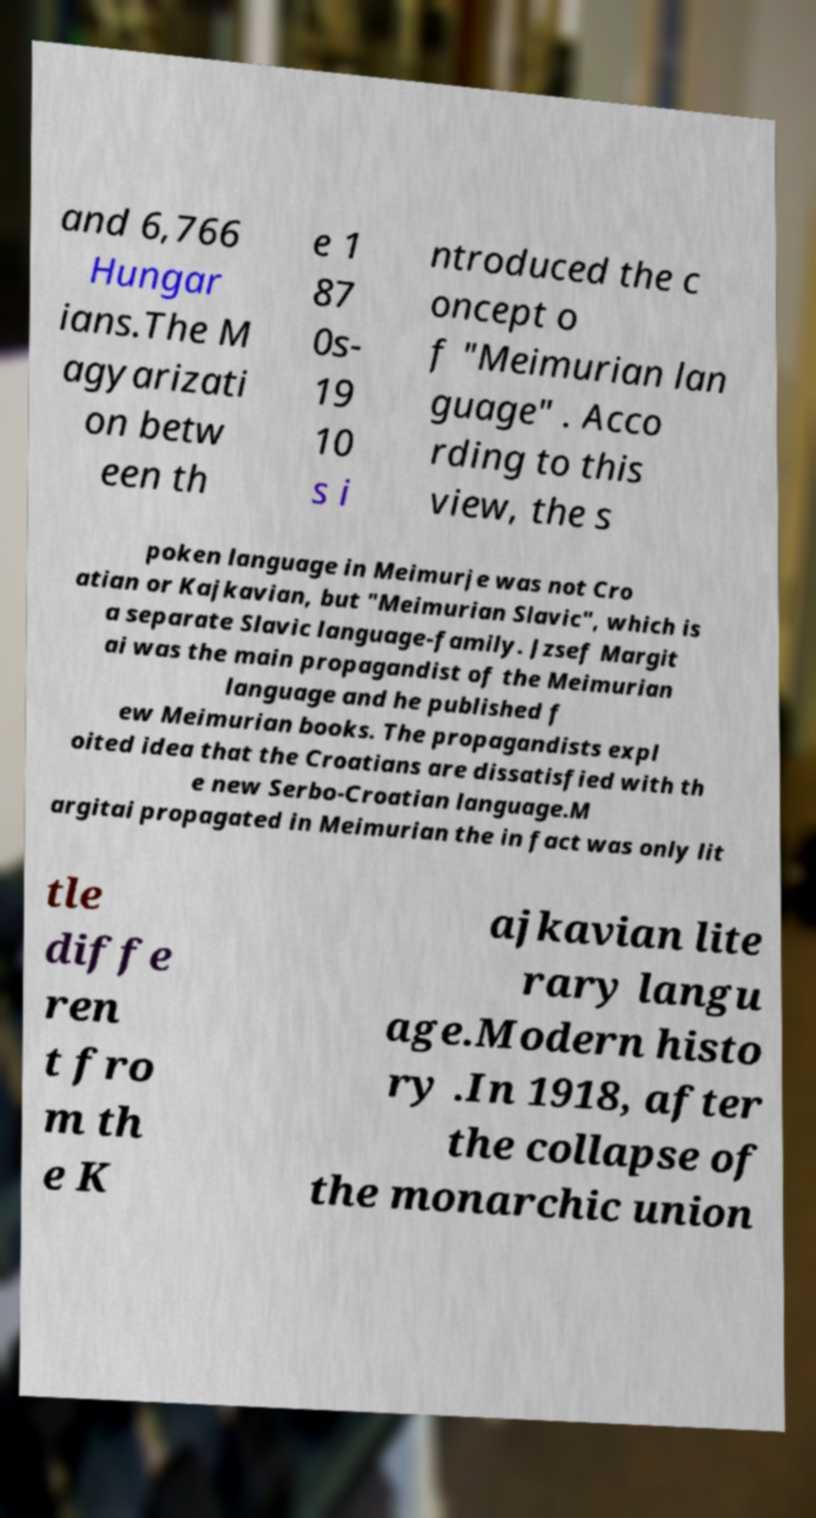Can you accurately transcribe the text from the provided image for me? and 6,766 Hungar ians.The M agyarizati on betw een th e 1 87 0s- 19 10 s i ntroduced the c oncept o f "Meimurian lan guage" . Acco rding to this view, the s poken language in Meimurje was not Cro atian or Kajkavian, but "Meimurian Slavic", which is a separate Slavic language-family. Jzsef Margit ai was the main propagandist of the Meimurian language and he published f ew Meimurian books. The propagandists expl oited idea that the Croatians are dissatisfied with th e new Serbo-Croatian language.M argitai propagated in Meimurian the in fact was only lit tle diffe ren t fro m th e K ajkavian lite rary langu age.Modern histo ry .In 1918, after the collapse of the monarchic union 